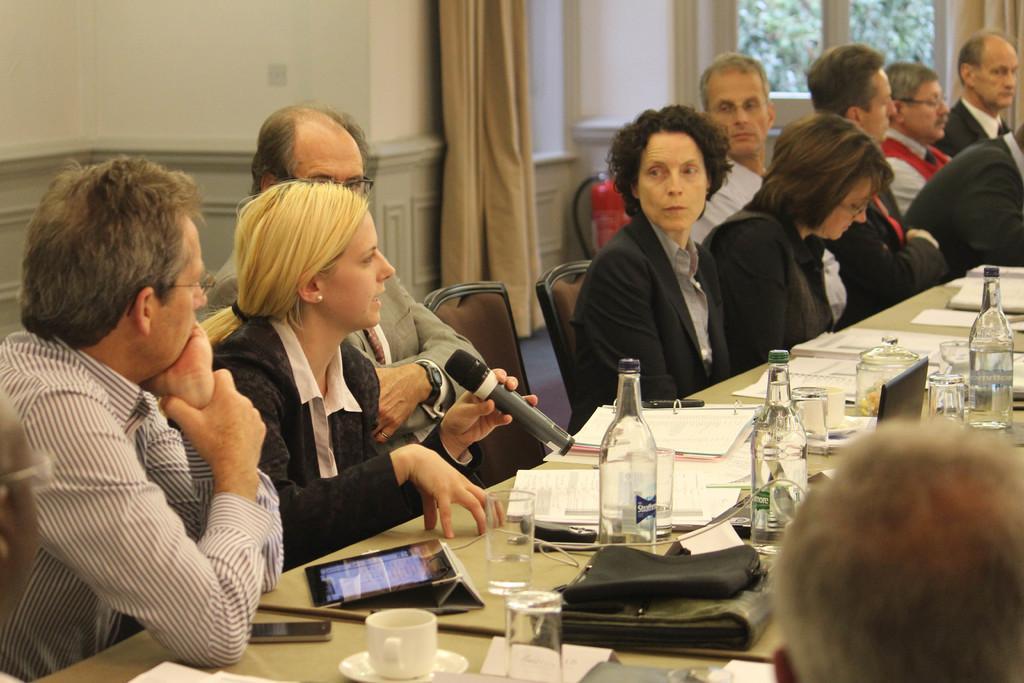Please provide a concise description of this image. This picture describes about group of people, they are all seated on the chairs, in front of them we can find few bottles, papers, files, mobiles, cup, glasses and other things on the table, behind them we can find curtains and trees. 